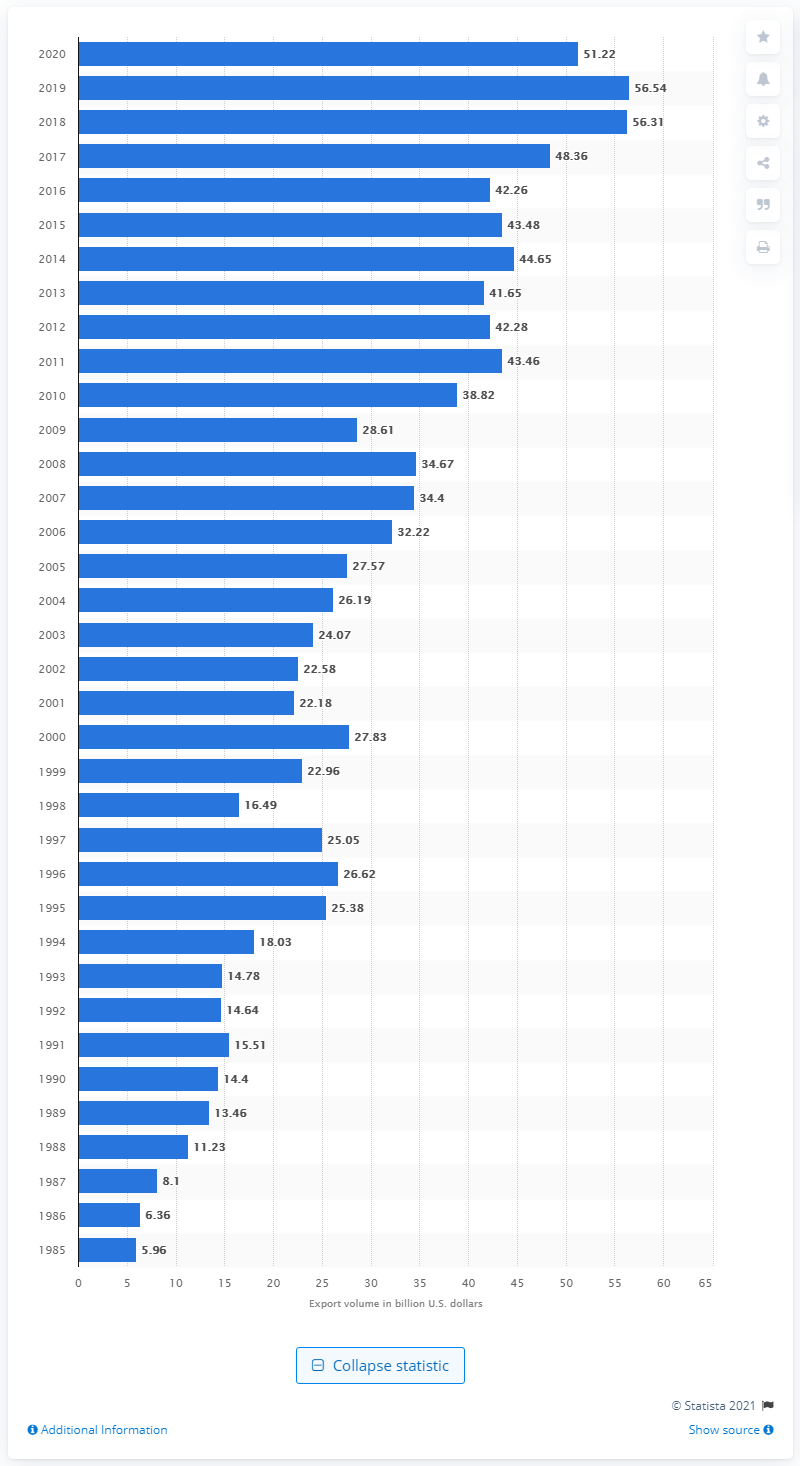Outline some significant characteristics in this image. In 2020, the value of U.S. exports to South Korea was 51.22 billion dollars. 